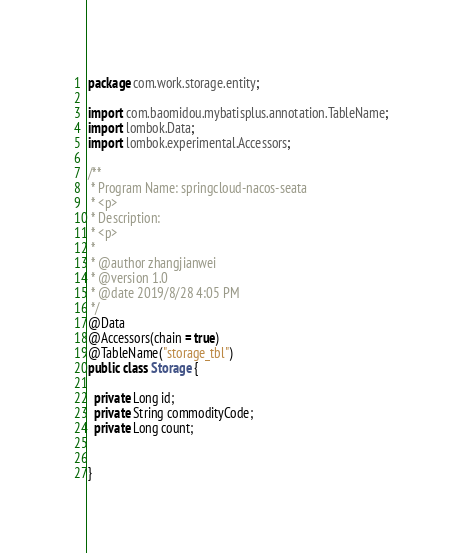Convert code to text. <code><loc_0><loc_0><loc_500><loc_500><_Java_>package com.work.storage.entity;

import com.baomidou.mybatisplus.annotation.TableName;
import lombok.Data;
import lombok.experimental.Accessors;

/**
 * Program Name: springcloud-nacos-seata
 * <p>
 * Description:
 * <p>
 *
 * @author zhangjianwei
 * @version 1.0
 * @date 2019/8/28 4:05 PM
 */
@Data
@Accessors(chain = true)
@TableName("storage_tbl")
public class Storage {

  private Long id;
  private String commodityCode;
  private Long count;


}
</code> 